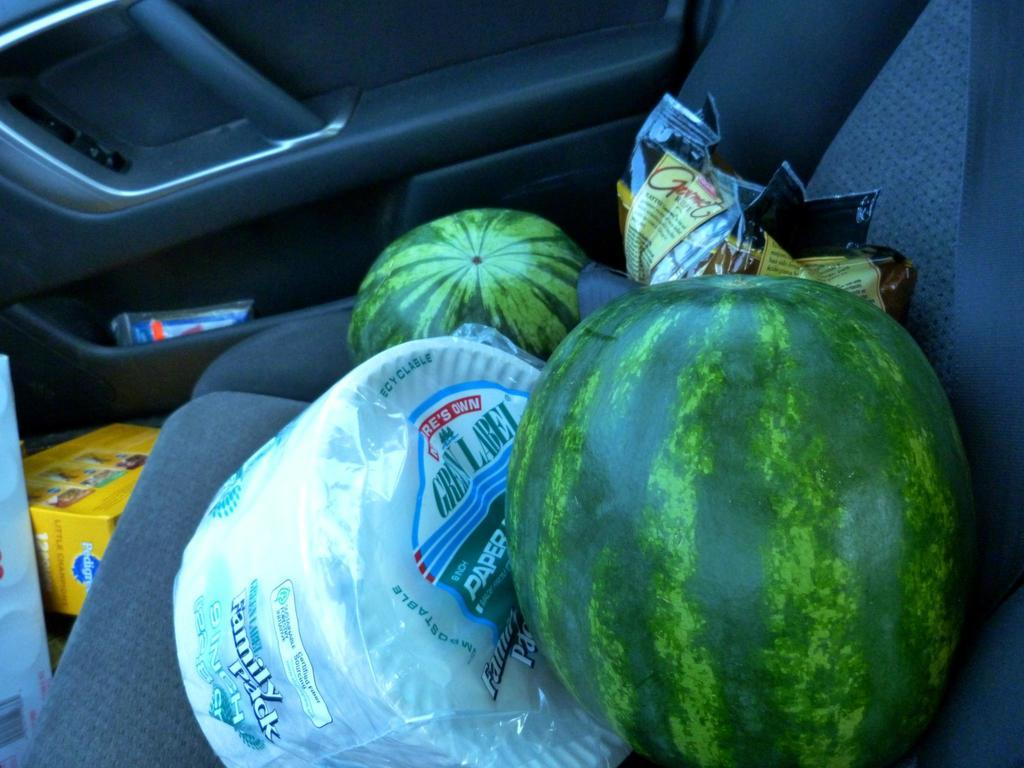What type of fruit can be seen inside the car in the image? There are two watermelons inside the car. What else can be seen inside the car besides the watermelons? There are other groceries inside the car. Where are the groceries located in the car? The groceries are on a car seat. What direction is the needle pointing to in the image? There is no needle present in the image. 